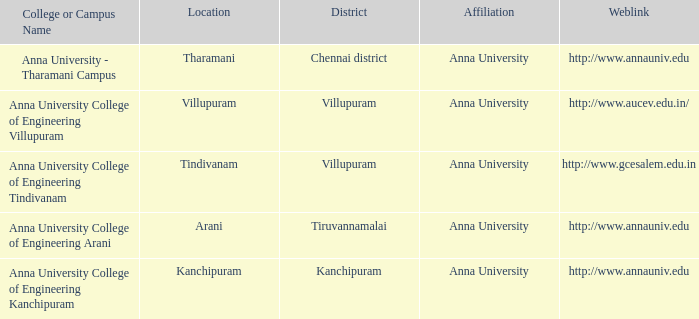What Location has a College or Campus Name of anna university - tharamani campus? Tharamani. 